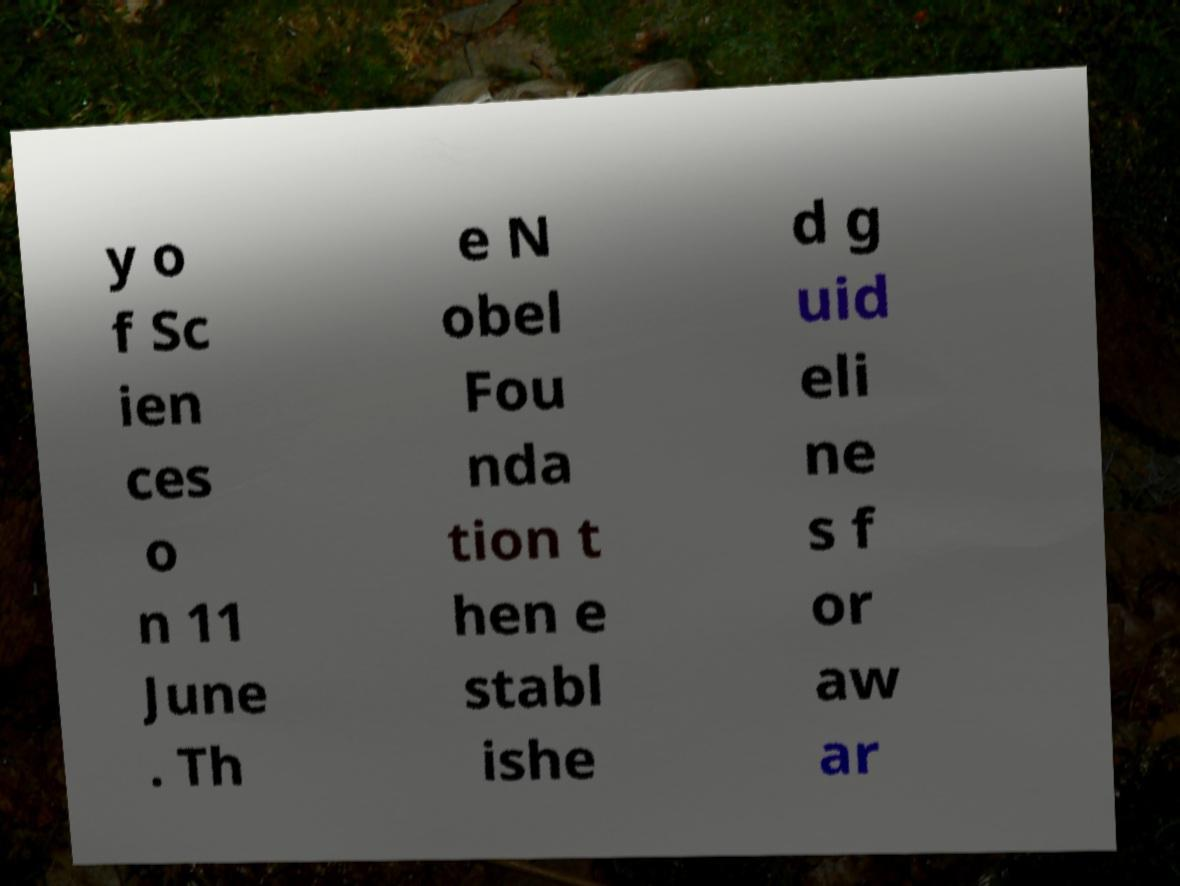Could you extract and type out the text from this image? y o f Sc ien ces o n 11 June . Th e N obel Fou nda tion t hen e stabl ishe d g uid eli ne s f or aw ar 